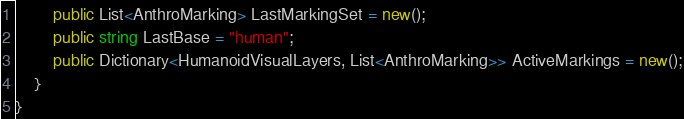<code> <loc_0><loc_0><loc_500><loc_500><_C#_>        public List<AnthroMarking> LastMarkingSet = new();
        public string LastBase = "human";
        public Dictionary<HumanoidVisualLayers, List<AnthroMarking>> ActiveMarkings = new();
    }
}
</code> 